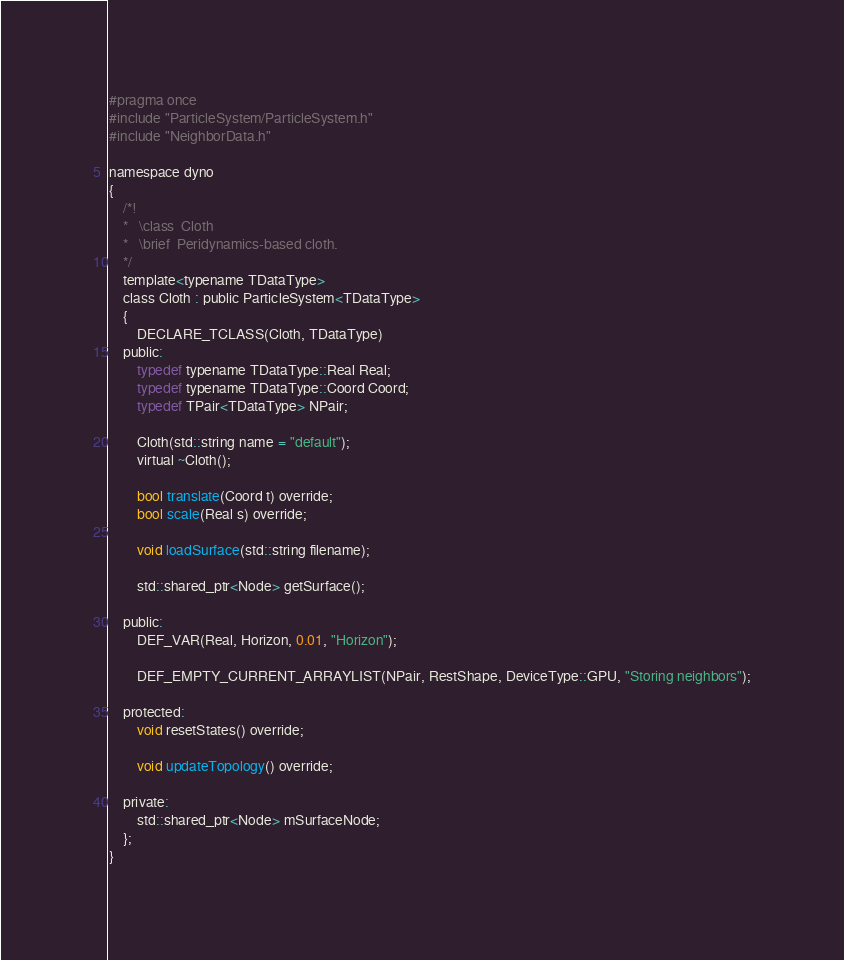Convert code to text. <code><loc_0><loc_0><loc_500><loc_500><_C_>#pragma once
#include "ParticleSystem/ParticleSystem.h"
#include "NeighborData.h"

namespace dyno
{
	/*!
	*	\class	Cloth
	*	\brief	Peridynamics-based cloth.
	*/
	template<typename TDataType>
	class Cloth : public ParticleSystem<TDataType>
	{
		DECLARE_TCLASS(Cloth, TDataType)
	public:
		typedef typename TDataType::Real Real;
		typedef typename TDataType::Coord Coord;
		typedef TPair<TDataType> NPair;

		Cloth(std::string name = "default");
		virtual ~Cloth();

		bool translate(Coord t) override;
		bool scale(Real s) override;

		void loadSurface(std::string filename);

		std::shared_ptr<Node> getSurface();

	public:
		DEF_VAR(Real, Horizon, 0.01, "Horizon");

		DEF_EMPTY_CURRENT_ARRAYLIST(NPair, RestShape, DeviceType::GPU, "Storing neighbors");

	protected:
		void resetStates() override;

		void updateTopology() override;

	private:
		std::shared_ptr<Node> mSurfaceNode;
	};
}</code> 